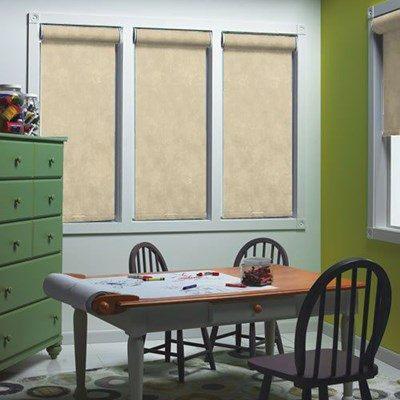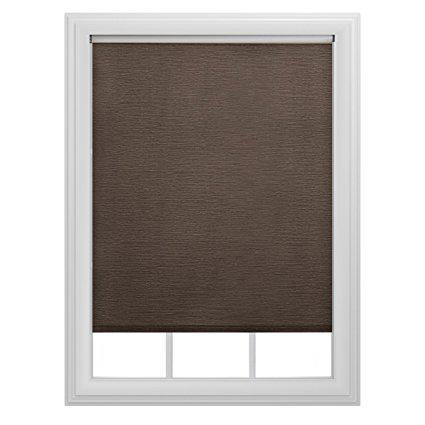The first image is the image on the left, the second image is the image on the right. Analyze the images presented: Is the assertion "At least one of the images is focused on a single window, with a black shade drawn most of the way down." valid? Answer yes or no. Yes. The first image is the image on the left, the second image is the image on the right. Evaluate the accuracy of this statement regarding the images: "The left and right image contains the same number of blinds.". Is it true? Answer yes or no. No. 